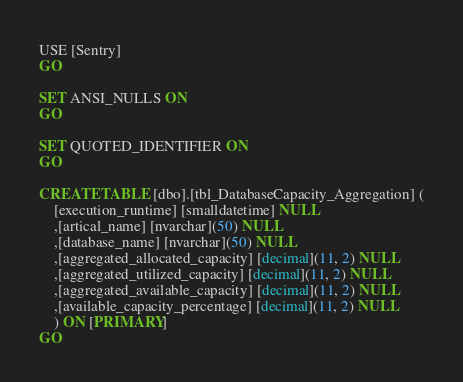<code> <loc_0><loc_0><loc_500><loc_500><_SQL_>USE [Sentry]
GO

SET ANSI_NULLS ON
GO

SET QUOTED_IDENTIFIER ON
GO

CREATE TABLE [dbo].[tbl_DatabaseCapacity_Aggregation] (
	[execution_runtime] [smalldatetime] NULL
	,[artical_name] [nvarchar](50) NULL
	,[database_name] [nvarchar](50) NULL
	,[aggregated_allocated_capacity] [decimal](11, 2) NULL
	,[aggregated_utilized_capacity] [decimal](11, 2) NULL
	,[aggregated_available_capacity] [decimal](11, 2) NULL
	,[available_capacity_percentage] [decimal](11, 2) NULL
	) ON [PRIMARY]
GO</code> 